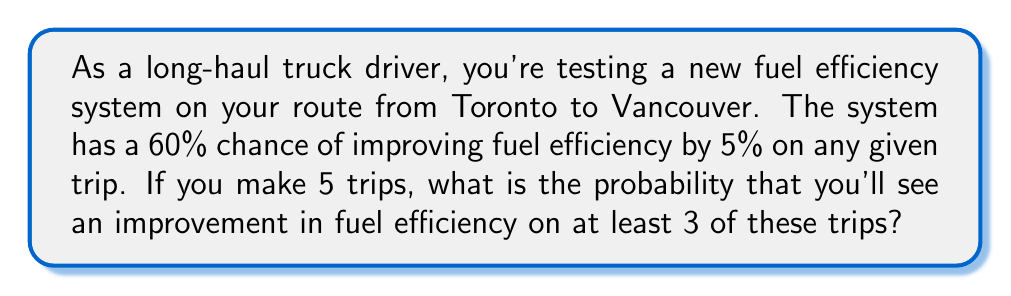Help me with this question. Let's approach this step-by-step using the binomial probability distribution:

1) We can model this scenario as a binomial experiment because:
   - There are a fixed number of trials (5 trips)
   - Each trial has two possible outcomes (improvement or no improvement)
   - The probability of success (improvement) is constant (60% or 0.6)
   - The trials are independent

2) We want the probability of at least 3 successes out of 5 trials. This means we need to calculate:
   P(3 successes) + P(4 successes) + P(5 successes)

3) The binomial probability formula is:

   $$P(X = k) = \binom{n}{k} p^k (1-p)^{n-k}$$

   Where:
   $n$ = number of trials (5)
   $k$ = number of successes
   $p$ = probability of success on each trial (0.6)

4) Let's calculate each probability:

   For 3 successes:
   $$P(X = 3) = \binom{5}{3} (0.6)^3 (0.4)^2 = 10 \cdot 0.216 \cdot 0.16 = 0.3456$$

   For 4 successes:
   $$P(X = 4) = \binom{5}{4} (0.6)^4 (0.4)^1 = 5 \cdot 0.1296 \cdot 0.4 = 0.2592$$

   For 5 successes:
   $$P(X = 5) = \binom{5}{5} (0.6)^5 (0.4)^0 = 1 \cdot 0.07776 \cdot 1 = 0.07776$$

5) Now, we sum these probabilities:

   $$P(X \geq 3) = 0.3456 + 0.2592 + 0.07776 = 0.68256$$

6) Therefore, the probability of seeing an improvement in fuel efficiency on at least 3 out of 5 trips is approximately 0.6826 or 68.26%.
Answer: 0.6826 or 68.26% 